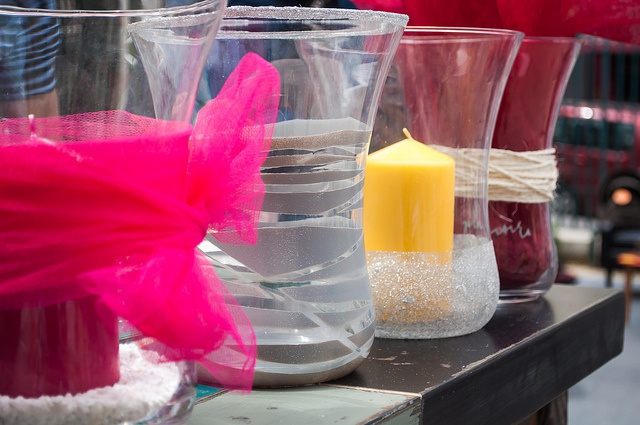Describe the objects in this image and their specific colors. I can see vase in blue, darkgray, gray, and lightgray tones, vase in blue, brown, darkgray, orange, and tan tones, vase in blue, gray, darkgray, lightgray, and black tones, dining table in blue, black, darkgray, and gray tones, and vase in blue, maroon, brown, gray, and black tones in this image. 